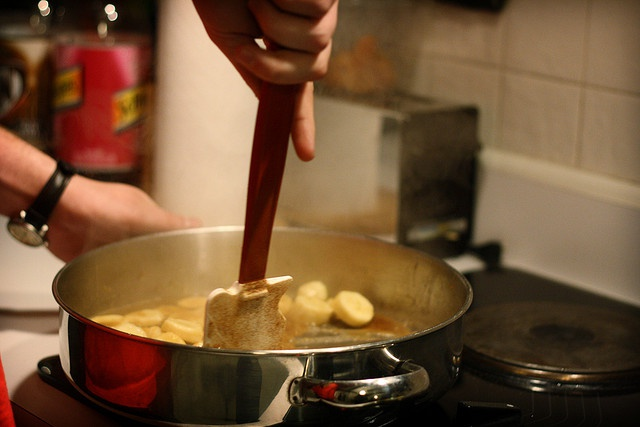Describe the objects in this image and their specific colors. I can see oven in black, gray, and tan tones, people in black, maroon, and tan tones, bottle in black, brown, and maroon tones, banana in black, orange, khaki, and olive tones, and banana in black, orange, and gold tones in this image. 